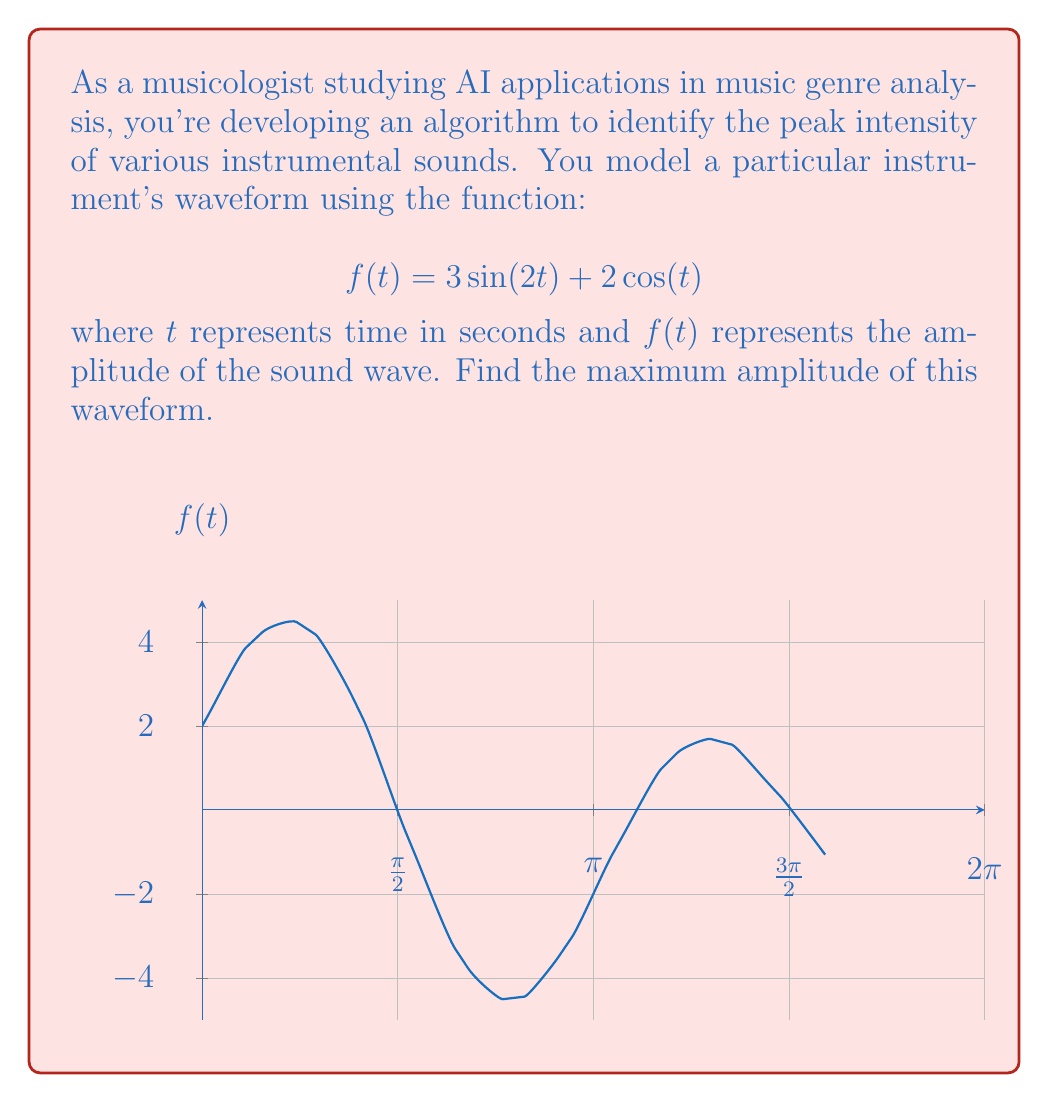What is the answer to this math problem? To find the maximum amplitude, we need to find the global maximum of the function $f(t) = 3\sin(2t) + 2\cos(t)$. We can do this using derivatives:

1) First, find the derivative of $f(t)$:
   $$f'(t) = 6\cos(2t) - 2\sin(t)$$

2) Set $f'(t) = 0$ to find critical points:
   $$6\cos(2t) - 2\sin(t) = 0$$

3) This equation is difficult to solve analytically. However, we can use an alternative approach for periodic functions.

4) Note that $f(t)$ is a combination of sine and cosine functions with periods of $\pi$ and $2\pi$. The overall period of $f(t)$ is $2\pi$.

5) We can rewrite $f(t)$ as a single sinusoid:
   $$f(t) = A\sin(2t + \phi)$$
   where $A$ is the amplitude and $\phi$ is the phase shift.

6) To find $A$, we can use the identity:
   $$A = \sqrt{a^2 + b^2}$$
   where $a$ and $b$ are the coefficients of $\sin(2t)$ and $\cos(t)$ respectively.

7) In this case:
   $$A = \sqrt{3^2 + 2^2} = \sqrt{9 + 4} = \sqrt{13}$$

8) The maximum amplitude of a sinusoid is equal to its amplitude $A$.

Therefore, the maximum amplitude of the waveform is $\sqrt{13}$.
Answer: $\sqrt{13}$ 